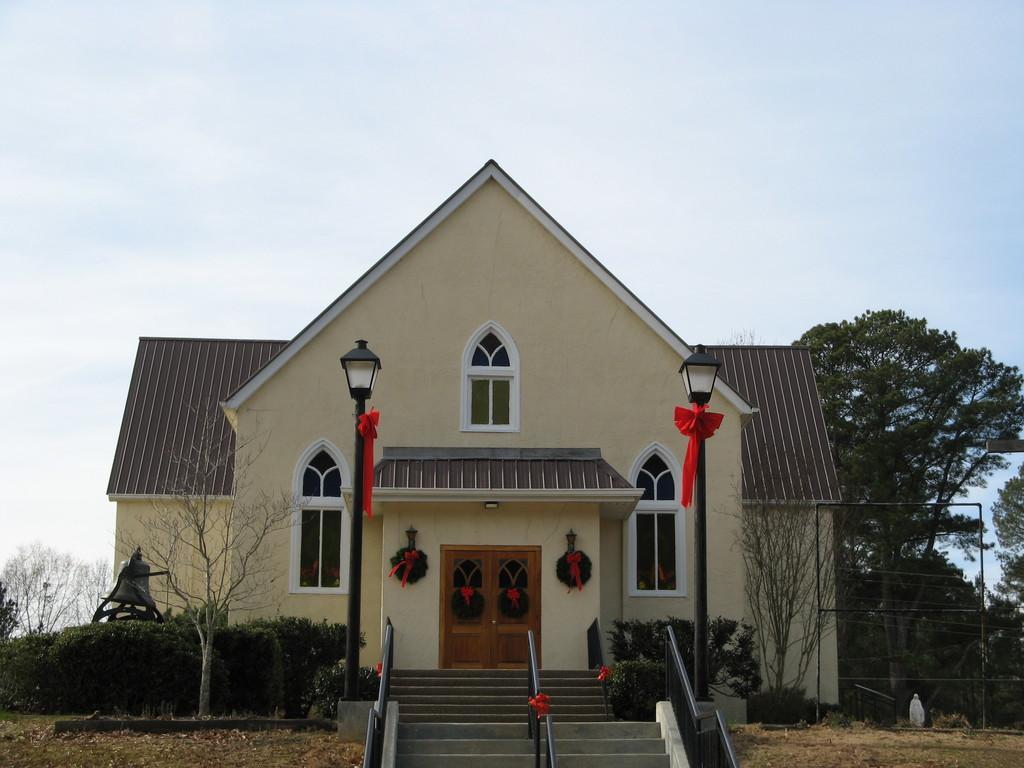Could you give a brief overview of what you see in this image? In this image I can see the stairs. I can also see a house. In the background, I can see the trees and the sky. 